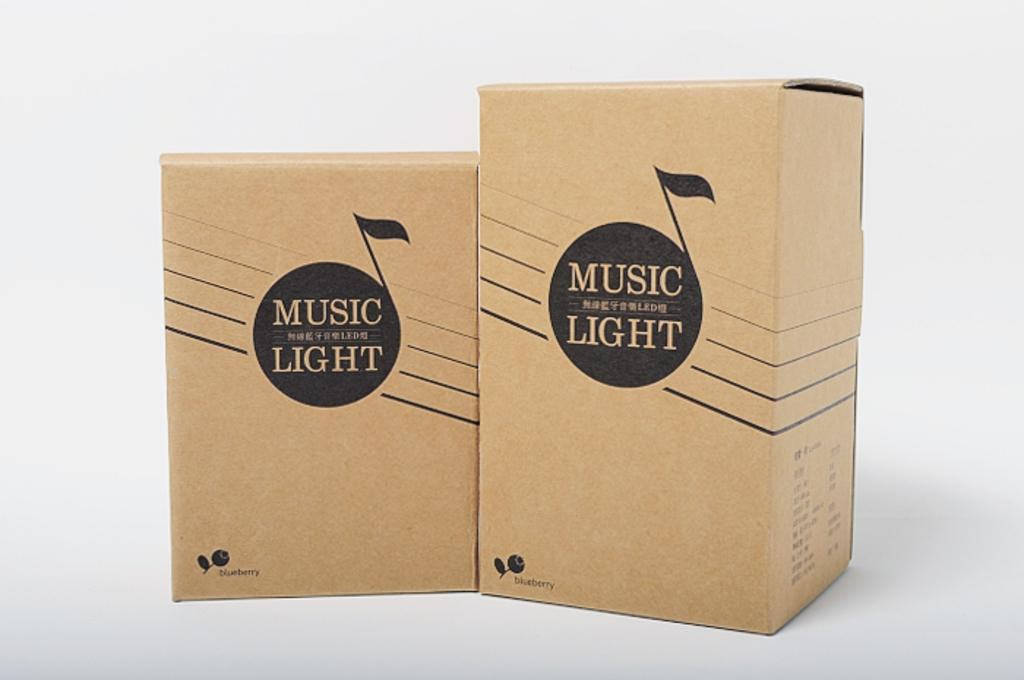Provide a one-sentence caption for the provided image. Two cardboard boxes side by side which contain music lights. 